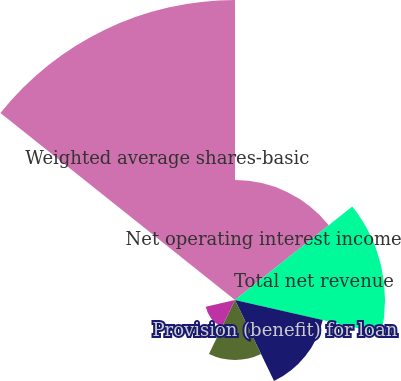Convert chart to OTSL. <chart><loc_0><loc_0><loc_500><loc_500><pie_chart><fcel>Net operating interest income<fcel>Total net revenue<fcel>Provision (benefit) for loan<fcel>Net income (loss)<fcel>Basic net earnings (loss) per<fcel>Diluted net earnings (loss)<fcel>Weighted average shares-basic<nl><fcel>16.0%<fcel>20.0%<fcel>12.0%<fcel>8.0%<fcel>4.0%<fcel>0.0%<fcel>40.0%<nl></chart> 